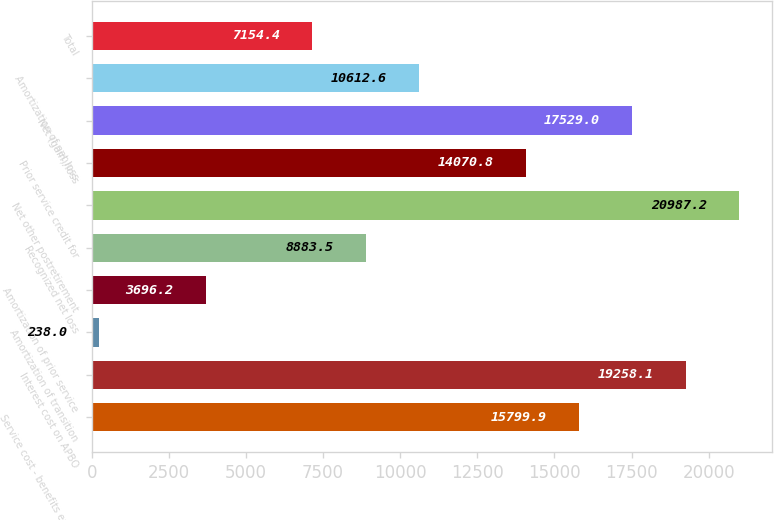Convert chart to OTSL. <chart><loc_0><loc_0><loc_500><loc_500><bar_chart><fcel>Service cost - benefits earned<fcel>Interest cost on APBO<fcel>Amortization of transition<fcel>Amortization of prior service<fcel>Recognized net loss<fcel>Net other postretirement<fcel>Prior service credit for<fcel>Net (gain)/loss<fcel>Amortization of net loss<fcel>Total<nl><fcel>15799.9<fcel>19258.1<fcel>238<fcel>3696.2<fcel>8883.5<fcel>20987.2<fcel>14070.8<fcel>17529<fcel>10612.6<fcel>7154.4<nl></chart> 